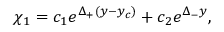Convert formula to latex. <formula><loc_0><loc_0><loc_500><loc_500>\chi _ { 1 } = c _ { 1 } e ^ { \Delta _ { + } ( y - y _ { c } ) } + c _ { 2 } e ^ { \Delta _ { - } y } ,</formula> 